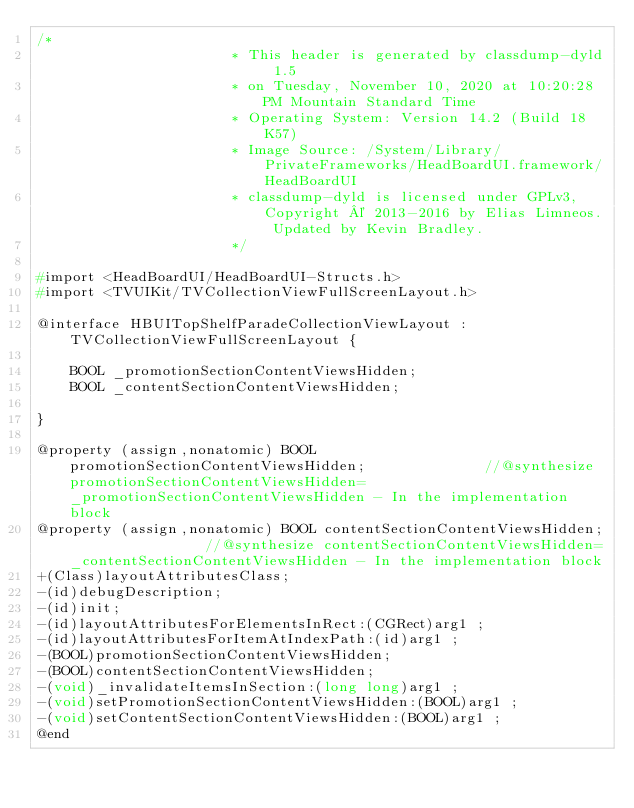Convert code to text. <code><loc_0><loc_0><loc_500><loc_500><_C_>/*
                       * This header is generated by classdump-dyld 1.5
                       * on Tuesday, November 10, 2020 at 10:20:28 PM Mountain Standard Time
                       * Operating System: Version 14.2 (Build 18K57)
                       * Image Source: /System/Library/PrivateFrameworks/HeadBoardUI.framework/HeadBoardUI
                       * classdump-dyld is licensed under GPLv3, Copyright © 2013-2016 by Elias Limneos. Updated by Kevin Bradley.
                       */

#import <HeadBoardUI/HeadBoardUI-Structs.h>
#import <TVUIKit/TVCollectionViewFullScreenLayout.h>

@interface HBUITopShelfParadeCollectionViewLayout : TVCollectionViewFullScreenLayout {

	BOOL _promotionSectionContentViewsHidden;
	BOOL _contentSectionContentViewsHidden;

}

@property (assign,nonatomic) BOOL promotionSectionContentViewsHidden;              //@synthesize promotionSectionContentViewsHidden=_promotionSectionContentViewsHidden - In the implementation block
@property (assign,nonatomic) BOOL contentSectionContentViewsHidden;                //@synthesize contentSectionContentViewsHidden=_contentSectionContentViewsHidden - In the implementation block
+(Class)layoutAttributesClass;
-(id)debugDescription;
-(id)init;
-(id)layoutAttributesForElementsInRect:(CGRect)arg1 ;
-(id)layoutAttributesForItemAtIndexPath:(id)arg1 ;
-(BOOL)promotionSectionContentViewsHidden;
-(BOOL)contentSectionContentViewsHidden;
-(void)_invalidateItemsInSection:(long long)arg1 ;
-(void)setPromotionSectionContentViewsHidden:(BOOL)arg1 ;
-(void)setContentSectionContentViewsHidden:(BOOL)arg1 ;
@end

</code> 